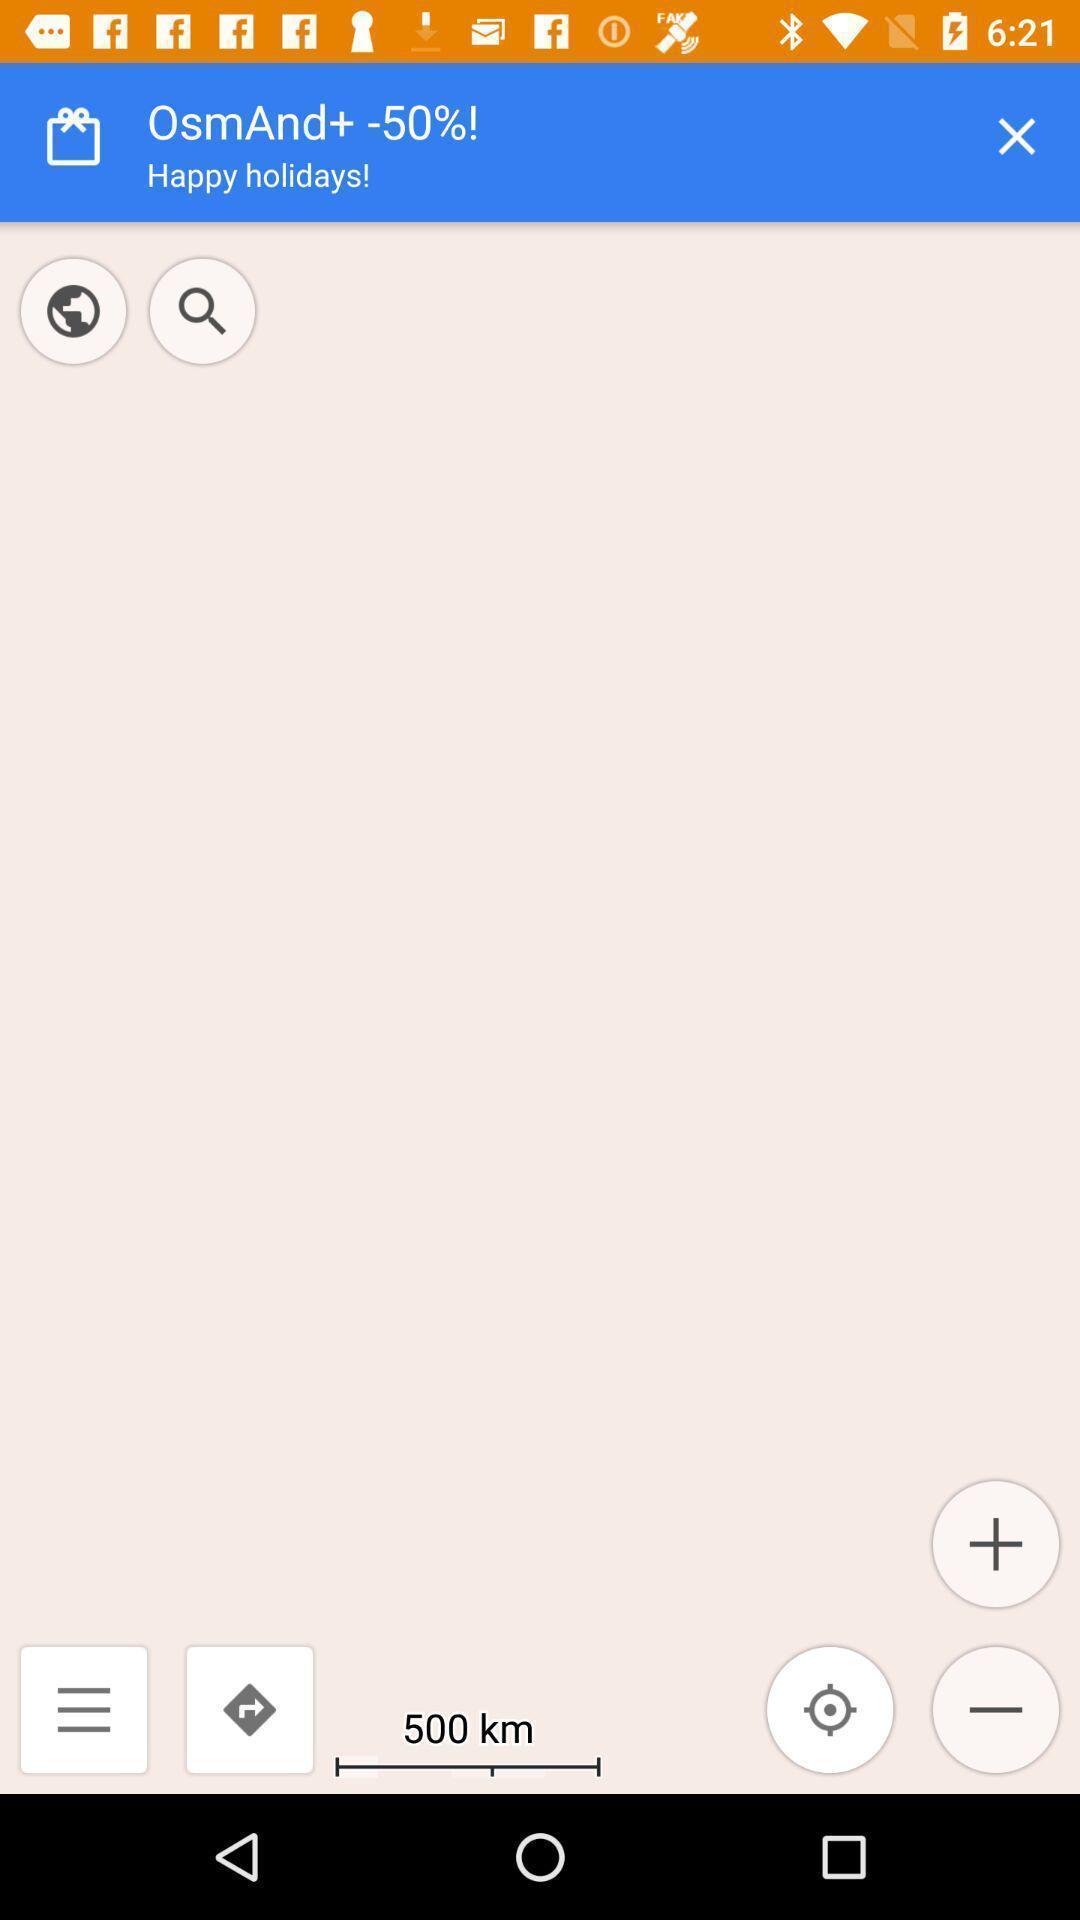Explain what's happening in this screen capture. Screen displaying the location page. 